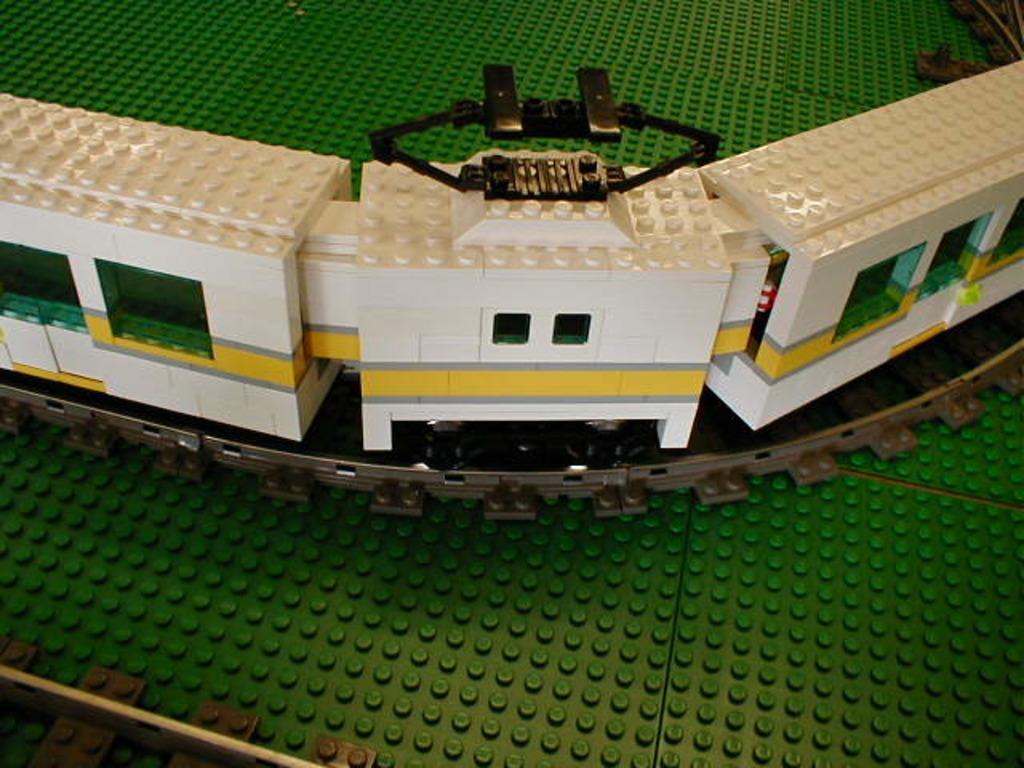Describe this image in one or two sentences. There is a white train on the track made up of lego bricks. There is a green surface. 